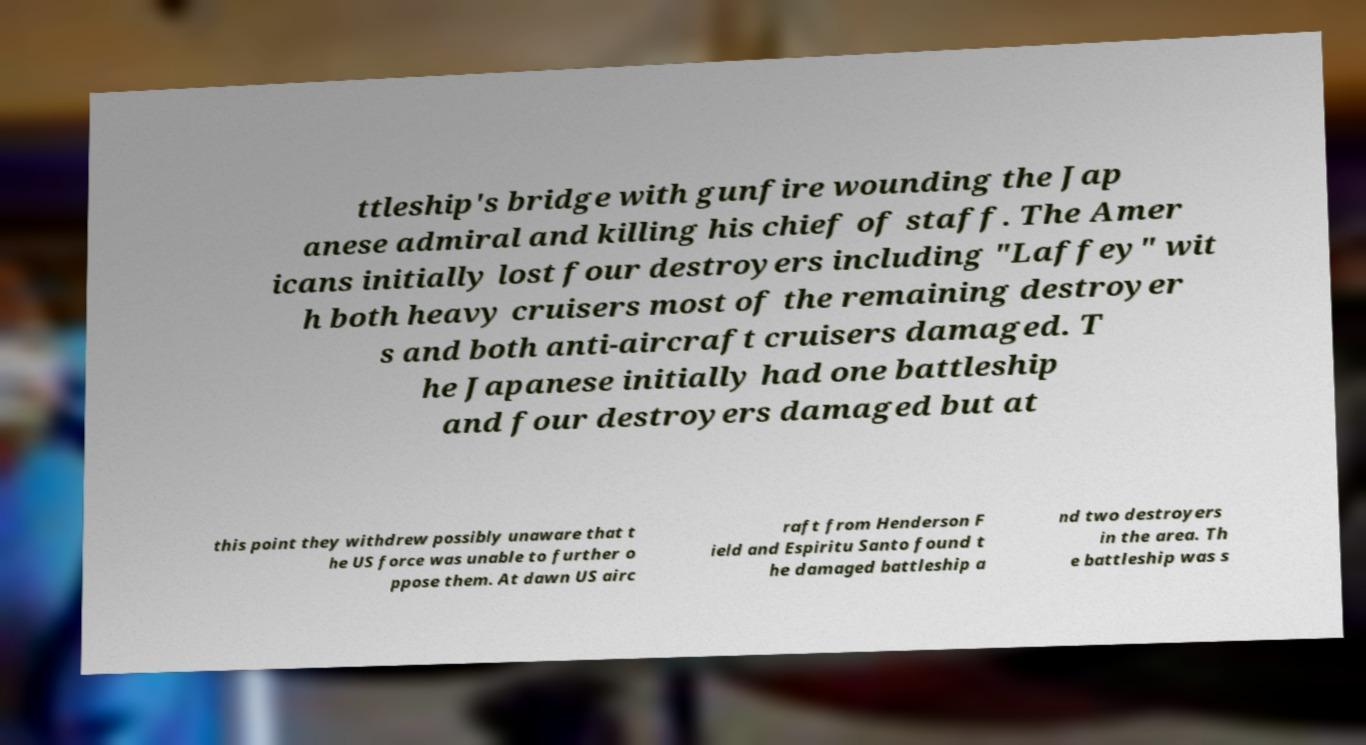Please read and relay the text visible in this image. What does it say? ttleship's bridge with gunfire wounding the Jap anese admiral and killing his chief of staff. The Amer icans initially lost four destroyers including "Laffey" wit h both heavy cruisers most of the remaining destroyer s and both anti-aircraft cruisers damaged. T he Japanese initially had one battleship and four destroyers damaged but at this point they withdrew possibly unaware that t he US force was unable to further o ppose them. At dawn US airc raft from Henderson F ield and Espiritu Santo found t he damaged battleship a nd two destroyers in the area. Th e battleship was s 